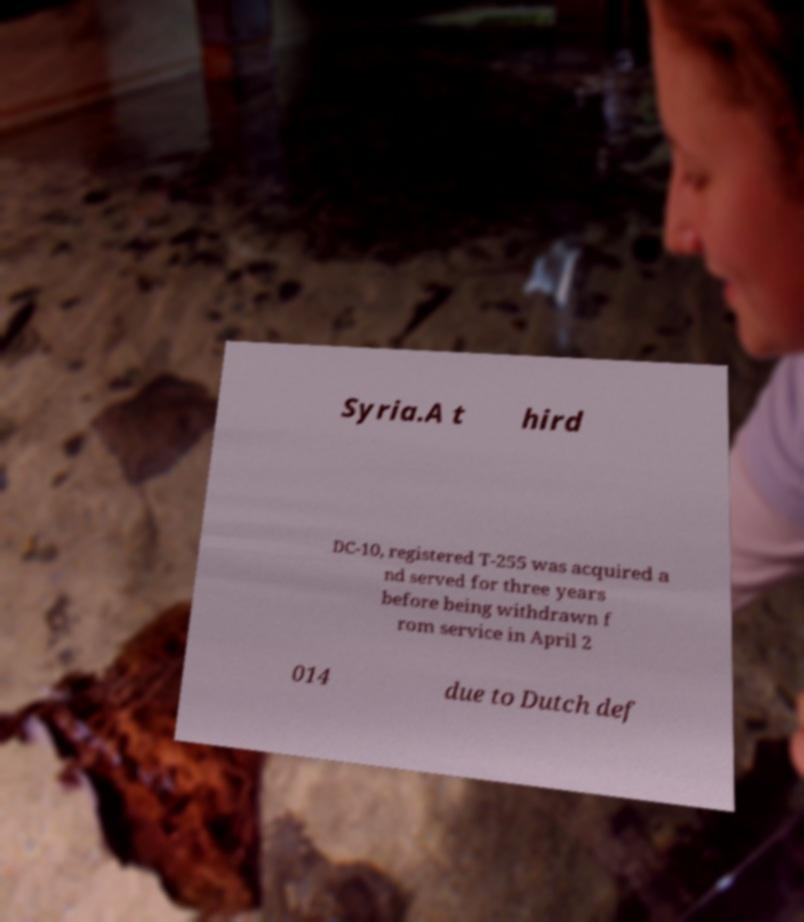I need the written content from this picture converted into text. Can you do that? Syria.A t hird DC-10, registered T-255 was acquired a nd served for three years before being withdrawn f rom service in April 2 014 due to Dutch def 